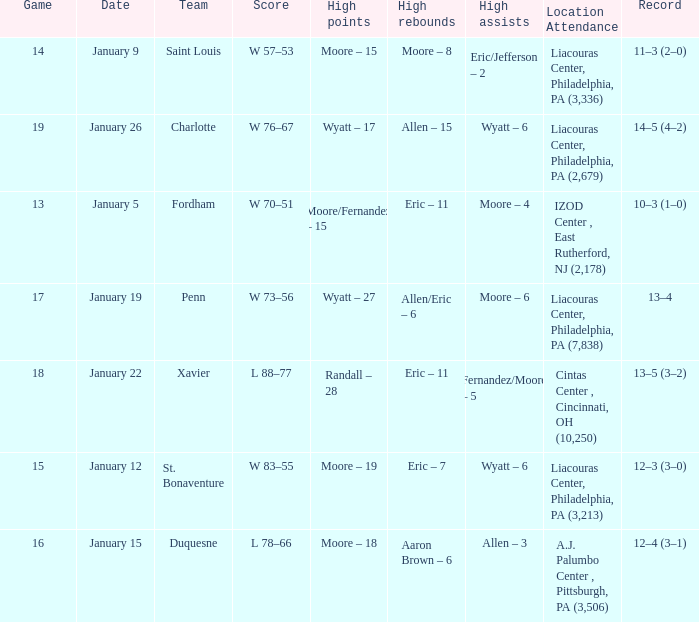Who had the most assists and how many did they have on January 5? Moore – 4. 